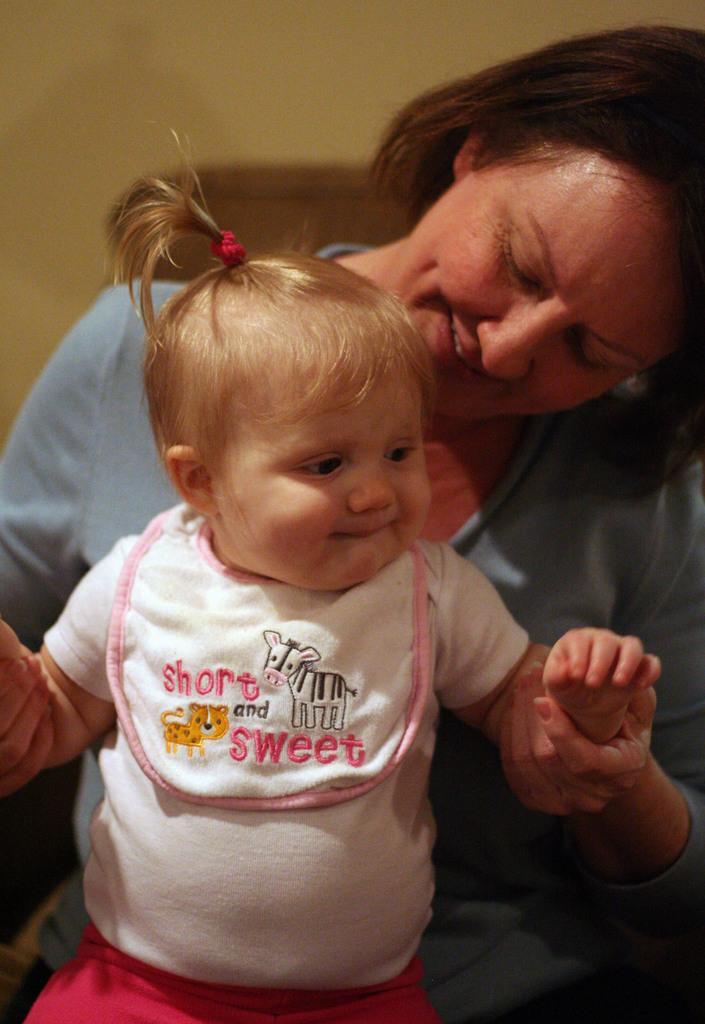In one or two sentences, can you explain what this image depicts? In this picture there is a woman holding a kid. Woman is wearing a blue top and kid is wearing a white top and red skirt. 